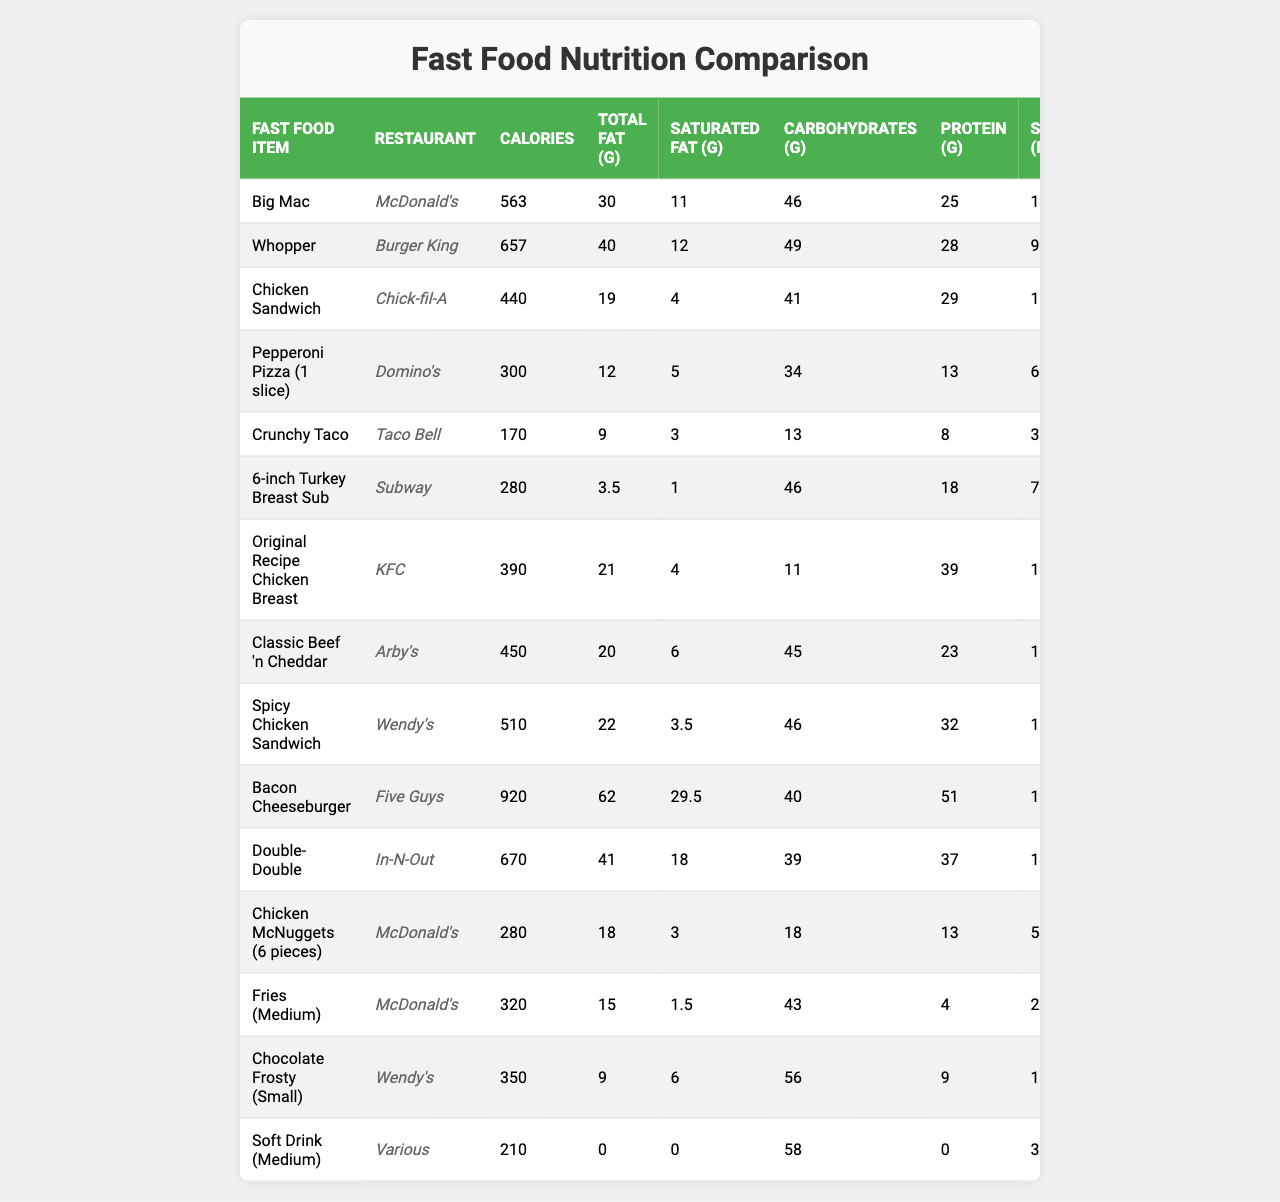What fast food item has the highest calorie count? The highest calorie count in the table is for the "Bacon Cheeseburger" from Five Guys, which has 920 calories.
Answer: Bacon Cheeseburger Which restaurant offers the least calorie item listed? The item with the least calories is the "Crunchy Taco" from Taco Bell, containing 170 calories.
Answer: Taco Bell How many grams of total fat are in the Whopper? The Whopper contains 40 grams of total fat, as indicated directly in the table.
Answer: 40 grams What is the combined sodium content of a Big Mac and Chicken Sandwich? The sodium content of the Big Mac is 1007 mg and the Chicken Sandwich has 1350 mg. Adding them gives 1007 + 1350 = 2357 mg total sodium.
Answer: 2357 mg Is the protein content in the Chicken McNuggets greater than that in the fries? The Chicken McNuggets have 13 grams of protein, while the fries have 4 grams. Since 13 > 4, the statement is true.
Answer: Yes What is the average calorie count of the fast food items from Chick-fil-A, Wendy's, and KFC? The calorie counts for these items are: Chick-fil-A Chicken Sandwich (440), Wendy's Spicy Chicken Sandwich (510), and KFC Original Recipe Chicken Breast (390). Summing these gives 440 + 510 + 390 = 1340, then dividing by 3 gives the average: 1340 / 3 = ~446.67.
Answer: ~446.67 Is there any item that contains more saturated fat than the Double-Double? The Double-Double has 18 grams of saturated fat. The Bacon Cheeseburger has 29.5 grams, and the Whopper has 12 grams. Since 29.5 > 18, the statement is true.
Answer: Yes What is the difference in carbohydrates between the Big Mac and the Classic Beef 'n Cheddar? The Big Mac has 46 grams of carbohydrates and the Classic Beef 'n Cheddar has 45 grams. The difference is 46 - 45 = 1 gram.
Answer: 1 gram Which item has more calories, the Medium Fries or the Chicken McNuggets? The Medium Fries have 320 calories and the Chicken McNuggets have 280 calories. Since 320 > 280, the fries have more calories.
Answer: Medium Fries What is the total protein contained in one Whopper and one Spicy Chicken Sandwich? The Whopper has 28 grams of protein and the Spicy Chicken Sandwich has 32 grams. The total is 28 + 32 = 60 grams of protein.
Answer: 60 grams 